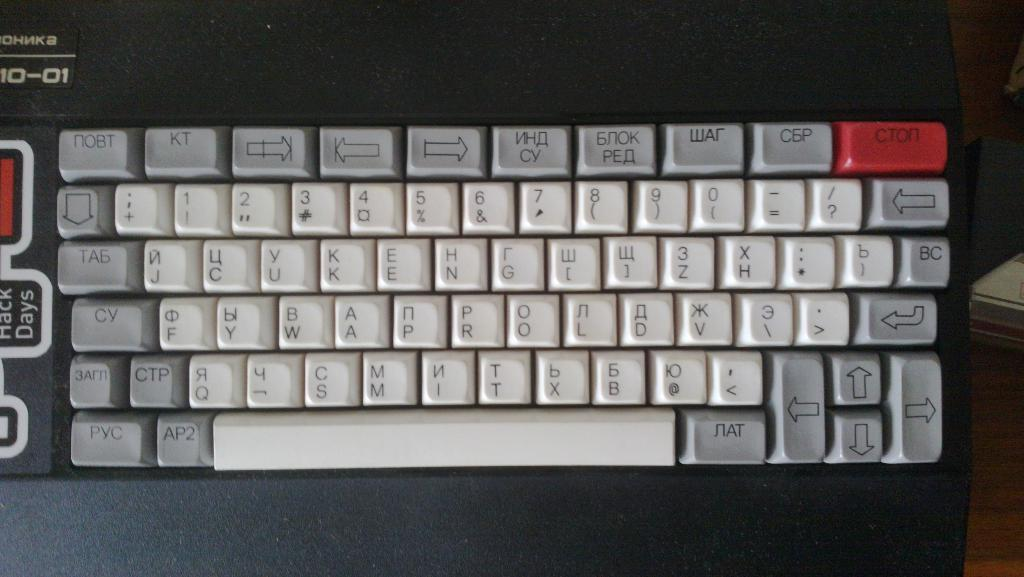<image>
Present a compact description of the photo's key features. A keyboard features a red key with the text "CTON" on it. 